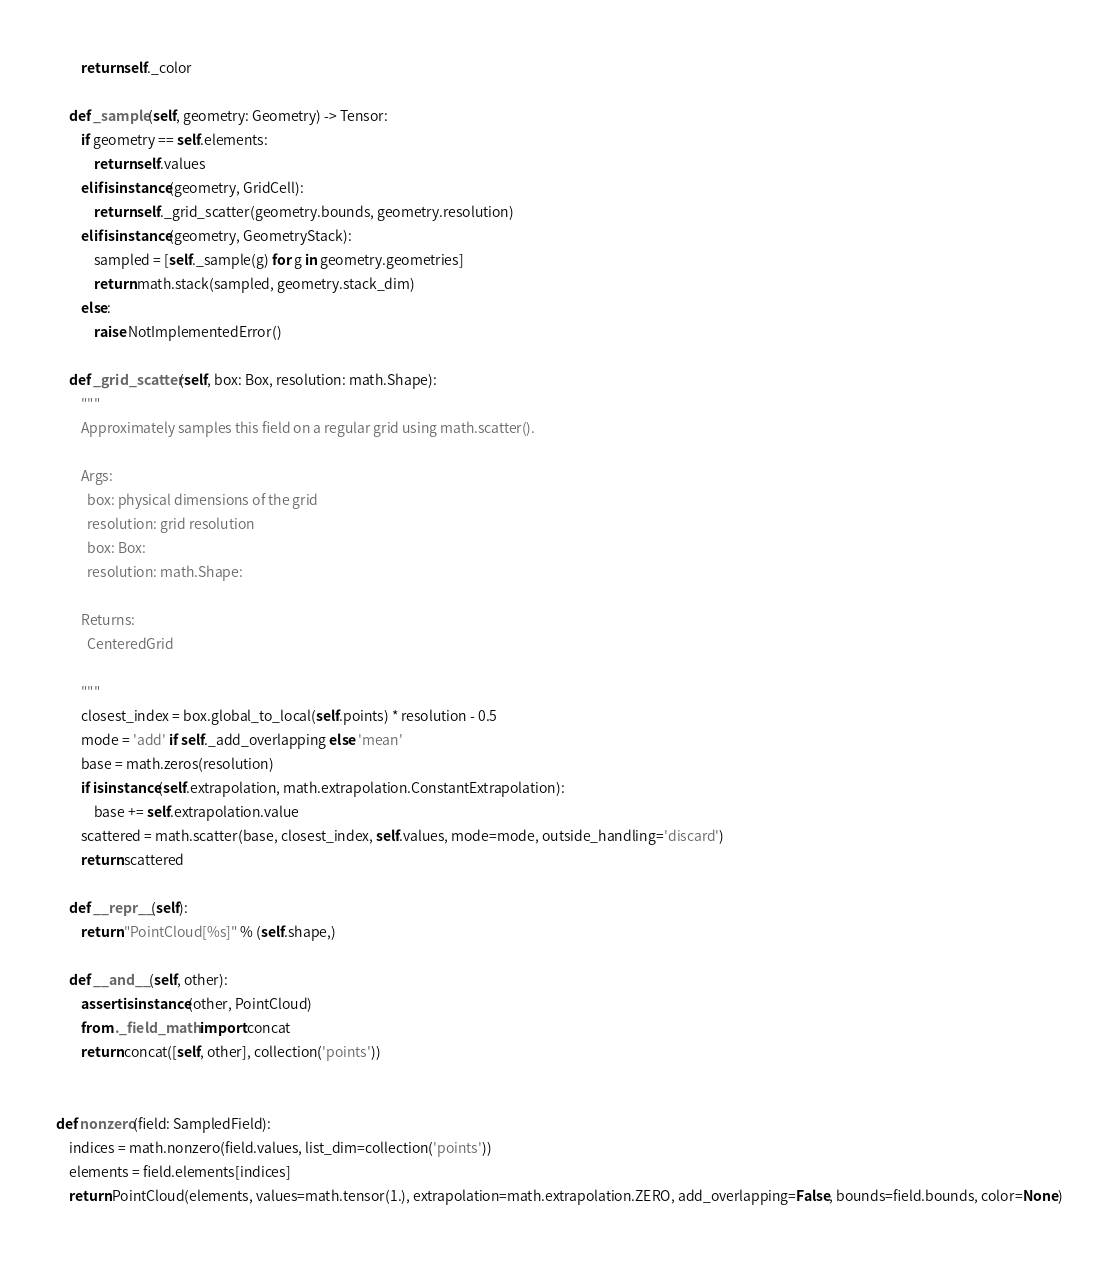Convert code to text. <code><loc_0><loc_0><loc_500><loc_500><_Python_>        return self._color

    def _sample(self, geometry: Geometry) -> Tensor:
        if geometry == self.elements:
            return self.values
        elif isinstance(geometry, GridCell):
            return self._grid_scatter(geometry.bounds, geometry.resolution)
        elif isinstance(geometry, GeometryStack):
            sampled = [self._sample(g) for g in geometry.geometries]
            return math.stack(sampled, geometry.stack_dim)
        else:
            raise NotImplementedError()

    def _grid_scatter(self, box: Box, resolution: math.Shape):
        """
        Approximately samples this field on a regular grid using math.scatter().

        Args:
          box: physical dimensions of the grid
          resolution: grid resolution
          box: Box: 
          resolution: math.Shape: 

        Returns:
          CenteredGrid

        """
        closest_index = box.global_to_local(self.points) * resolution - 0.5
        mode = 'add' if self._add_overlapping else 'mean'
        base = math.zeros(resolution)
        if isinstance(self.extrapolation, math.extrapolation.ConstantExtrapolation):
            base += self.extrapolation.value
        scattered = math.scatter(base, closest_index, self.values, mode=mode, outside_handling='discard')
        return scattered

    def __repr__(self):
        return "PointCloud[%s]" % (self.shape,)

    def __and__(self, other):
        assert isinstance(other, PointCloud)
        from ._field_math import concat
        return concat([self, other], collection('points'))


def nonzero(field: SampledField):
    indices = math.nonzero(field.values, list_dim=collection('points'))
    elements = field.elements[indices]
    return PointCloud(elements, values=math.tensor(1.), extrapolation=math.extrapolation.ZERO, add_overlapping=False, bounds=field.bounds, color=None)
</code> 